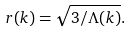<formula> <loc_0><loc_0><loc_500><loc_500>r ( k ) = \sqrt { 3 / \Lambda ( k ) } .</formula> 